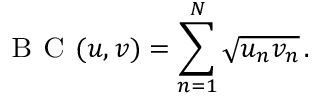Convert formula to latex. <formula><loc_0><loc_0><loc_500><loc_500>B C ( u , v ) = \sum _ { n = 1 } ^ { N } \sqrt { u _ { n } v _ { n } } \, .</formula> 